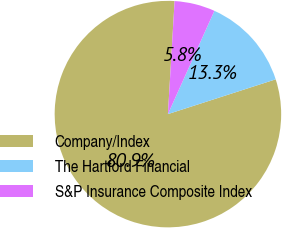Convert chart. <chart><loc_0><loc_0><loc_500><loc_500><pie_chart><fcel>Company/Index<fcel>The Hartford Financial<fcel>S&P Insurance Composite Index<nl><fcel>80.9%<fcel>13.3%<fcel>5.79%<nl></chart> 